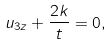Convert formula to latex. <formula><loc_0><loc_0><loc_500><loc_500>u _ { 3 z } + \frac { 2 k } { t } = 0 ,</formula> 